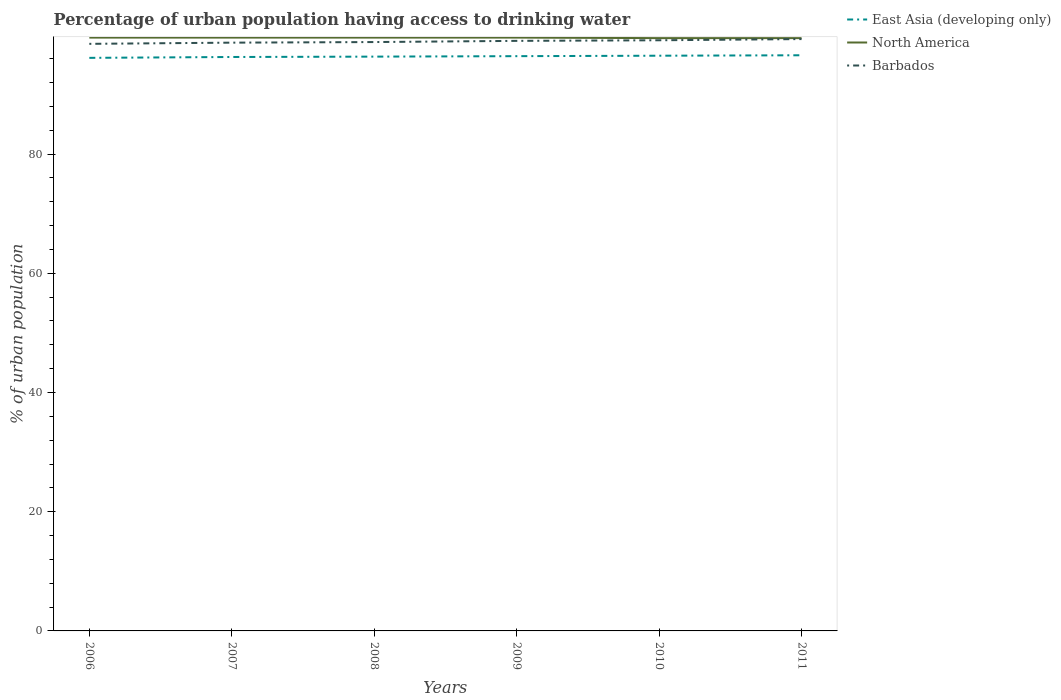Does the line corresponding to Barbados intersect with the line corresponding to East Asia (developing only)?
Give a very brief answer. No. Is the number of lines equal to the number of legend labels?
Your response must be concise. Yes. Across all years, what is the maximum percentage of urban population having access to drinking water in East Asia (developing only)?
Your response must be concise. 96.15. What is the total percentage of urban population having access to drinking water in East Asia (developing only) in the graph?
Your answer should be compact. -0.23. What is the difference between the highest and the second highest percentage of urban population having access to drinking water in East Asia (developing only)?
Give a very brief answer. 0.43. What is the difference between the highest and the lowest percentage of urban population having access to drinking water in North America?
Offer a very short reply. 4. Is the percentage of urban population having access to drinking water in East Asia (developing only) strictly greater than the percentage of urban population having access to drinking water in Barbados over the years?
Your answer should be compact. Yes. How many lines are there?
Give a very brief answer. 3. How many years are there in the graph?
Provide a short and direct response. 6. Does the graph contain grids?
Your answer should be very brief. No. How are the legend labels stacked?
Keep it short and to the point. Vertical. What is the title of the graph?
Your answer should be compact. Percentage of urban population having access to drinking water. What is the label or title of the Y-axis?
Ensure brevity in your answer.  % of urban population. What is the % of urban population of East Asia (developing only) in 2006?
Your answer should be very brief. 96.15. What is the % of urban population in North America in 2006?
Your answer should be compact. 99.55. What is the % of urban population of Barbados in 2006?
Provide a succinct answer. 98.5. What is the % of urban population of East Asia (developing only) in 2007?
Provide a short and direct response. 96.29. What is the % of urban population in North America in 2007?
Keep it short and to the point. 99.55. What is the % of urban population of Barbados in 2007?
Make the answer very short. 98.7. What is the % of urban population of East Asia (developing only) in 2008?
Your answer should be very brief. 96.36. What is the % of urban population in North America in 2008?
Make the answer very short. 99.55. What is the % of urban population of Barbados in 2008?
Provide a succinct answer. 98.8. What is the % of urban population of East Asia (developing only) in 2009?
Ensure brevity in your answer.  96.43. What is the % of urban population in North America in 2009?
Make the answer very short. 99.55. What is the % of urban population of East Asia (developing only) in 2010?
Make the answer very short. 96.51. What is the % of urban population in North America in 2010?
Keep it short and to the point. 99.46. What is the % of urban population of Barbados in 2010?
Offer a very short reply. 99.1. What is the % of urban population in East Asia (developing only) in 2011?
Ensure brevity in your answer.  96.58. What is the % of urban population in North America in 2011?
Your response must be concise. 99.46. What is the % of urban population of Barbados in 2011?
Offer a very short reply. 99.3. Across all years, what is the maximum % of urban population of East Asia (developing only)?
Your response must be concise. 96.58. Across all years, what is the maximum % of urban population of North America?
Make the answer very short. 99.55. Across all years, what is the maximum % of urban population in Barbados?
Ensure brevity in your answer.  99.3. Across all years, what is the minimum % of urban population of East Asia (developing only)?
Make the answer very short. 96.15. Across all years, what is the minimum % of urban population in North America?
Offer a terse response. 99.46. Across all years, what is the minimum % of urban population of Barbados?
Your answer should be compact. 98.5. What is the total % of urban population in East Asia (developing only) in the graph?
Ensure brevity in your answer.  578.33. What is the total % of urban population in North America in the graph?
Keep it short and to the point. 597.12. What is the total % of urban population in Barbados in the graph?
Provide a succinct answer. 593.4. What is the difference between the % of urban population in East Asia (developing only) in 2006 and that in 2007?
Provide a short and direct response. -0.14. What is the difference between the % of urban population of North America in 2006 and that in 2007?
Give a very brief answer. -0. What is the difference between the % of urban population in Barbados in 2006 and that in 2007?
Your answer should be very brief. -0.2. What is the difference between the % of urban population of East Asia (developing only) in 2006 and that in 2008?
Your answer should be compact. -0.21. What is the difference between the % of urban population of North America in 2006 and that in 2008?
Your answer should be compact. -0. What is the difference between the % of urban population of East Asia (developing only) in 2006 and that in 2009?
Give a very brief answer. -0.28. What is the difference between the % of urban population of North America in 2006 and that in 2009?
Offer a terse response. -0. What is the difference between the % of urban population of Barbados in 2006 and that in 2009?
Make the answer very short. -0.5. What is the difference between the % of urban population in East Asia (developing only) in 2006 and that in 2010?
Give a very brief answer. -0.36. What is the difference between the % of urban population in North America in 2006 and that in 2010?
Make the answer very short. 0.09. What is the difference between the % of urban population in East Asia (developing only) in 2006 and that in 2011?
Provide a short and direct response. -0.43. What is the difference between the % of urban population in North America in 2006 and that in 2011?
Provide a short and direct response. 0.09. What is the difference between the % of urban population in East Asia (developing only) in 2007 and that in 2008?
Your answer should be compact. -0.06. What is the difference between the % of urban population of North America in 2007 and that in 2008?
Offer a terse response. -0. What is the difference between the % of urban population in Barbados in 2007 and that in 2008?
Make the answer very short. -0.1. What is the difference between the % of urban population in East Asia (developing only) in 2007 and that in 2009?
Provide a succinct answer. -0.14. What is the difference between the % of urban population of North America in 2007 and that in 2009?
Give a very brief answer. -0. What is the difference between the % of urban population in Barbados in 2007 and that in 2009?
Provide a succinct answer. -0.3. What is the difference between the % of urban population of East Asia (developing only) in 2007 and that in 2010?
Offer a very short reply. -0.22. What is the difference between the % of urban population in North America in 2007 and that in 2010?
Your answer should be compact. 0.09. What is the difference between the % of urban population in Barbados in 2007 and that in 2010?
Your answer should be compact. -0.4. What is the difference between the % of urban population of East Asia (developing only) in 2007 and that in 2011?
Your answer should be very brief. -0.29. What is the difference between the % of urban population in North America in 2007 and that in 2011?
Keep it short and to the point. 0.09. What is the difference between the % of urban population of East Asia (developing only) in 2008 and that in 2009?
Ensure brevity in your answer.  -0.08. What is the difference between the % of urban population of North America in 2008 and that in 2009?
Provide a succinct answer. -0. What is the difference between the % of urban population in East Asia (developing only) in 2008 and that in 2010?
Your answer should be compact. -0.15. What is the difference between the % of urban population in North America in 2008 and that in 2010?
Give a very brief answer. 0.09. What is the difference between the % of urban population of East Asia (developing only) in 2008 and that in 2011?
Offer a very short reply. -0.23. What is the difference between the % of urban population of North America in 2008 and that in 2011?
Ensure brevity in your answer.  0.09. What is the difference between the % of urban population in East Asia (developing only) in 2009 and that in 2010?
Provide a succinct answer. -0.08. What is the difference between the % of urban population of North America in 2009 and that in 2010?
Offer a very short reply. 0.09. What is the difference between the % of urban population in Barbados in 2009 and that in 2010?
Offer a terse response. -0.1. What is the difference between the % of urban population in East Asia (developing only) in 2009 and that in 2011?
Your response must be concise. -0.15. What is the difference between the % of urban population in North America in 2009 and that in 2011?
Provide a succinct answer. 0.09. What is the difference between the % of urban population in Barbados in 2009 and that in 2011?
Make the answer very short. -0.3. What is the difference between the % of urban population of East Asia (developing only) in 2010 and that in 2011?
Give a very brief answer. -0.07. What is the difference between the % of urban population in North America in 2010 and that in 2011?
Give a very brief answer. -0. What is the difference between the % of urban population of East Asia (developing only) in 2006 and the % of urban population of North America in 2007?
Offer a terse response. -3.4. What is the difference between the % of urban population in East Asia (developing only) in 2006 and the % of urban population in Barbados in 2007?
Your answer should be very brief. -2.55. What is the difference between the % of urban population of North America in 2006 and the % of urban population of Barbados in 2007?
Provide a short and direct response. 0.85. What is the difference between the % of urban population of East Asia (developing only) in 2006 and the % of urban population of North America in 2008?
Your answer should be compact. -3.4. What is the difference between the % of urban population in East Asia (developing only) in 2006 and the % of urban population in Barbados in 2008?
Keep it short and to the point. -2.65. What is the difference between the % of urban population of North America in 2006 and the % of urban population of Barbados in 2008?
Make the answer very short. 0.75. What is the difference between the % of urban population of East Asia (developing only) in 2006 and the % of urban population of North America in 2009?
Keep it short and to the point. -3.4. What is the difference between the % of urban population in East Asia (developing only) in 2006 and the % of urban population in Barbados in 2009?
Offer a very short reply. -2.85. What is the difference between the % of urban population of North America in 2006 and the % of urban population of Barbados in 2009?
Keep it short and to the point. 0.55. What is the difference between the % of urban population of East Asia (developing only) in 2006 and the % of urban population of North America in 2010?
Provide a short and direct response. -3.31. What is the difference between the % of urban population in East Asia (developing only) in 2006 and the % of urban population in Barbados in 2010?
Provide a succinct answer. -2.95. What is the difference between the % of urban population of North America in 2006 and the % of urban population of Barbados in 2010?
Provide a short and direct response. 0.45. What is the difference between the % of urban population of East Asia (developing only) in 2006 and the % of urban population of North America in 2011?
Your answer should be very brief. -3.31. What is the difference between the % of urban population of East Asia (developing only) in 2006 and the % of urban population of Barbados in 2011?
Offer a terse response. -3.15. What is the difference between the % of urban population in North America in 2006 and the % of urban population in Barbados in 2011?
Offer a very short reply. 0.25. What is the difference between the % of urban population of East Asia (developing only) in 2007 and the % of urban population of North America in 2008?
Ensure brevity in your answer.  -3.26. What is the difference between the % of urban population in East Asia (developing only) in 2007 and the % of urban population in Barbados in 2008?
Keep it short and to the point. -2.51. What is the difference between the % of urban population in North America in 2007 and the % of urban population in Barbados in 2008?
Provide a short and direct response. 0.75. What is the difference between the % of urban population in East Asia (developing only) in 2007 and the % of urban population in North America in 2009?
Offer a very short reply. -3.26. What is the difference between the % of urban population of East Asia (developing only) in 2007 and the % of urban population of Barbados in 2009?
Offer a terse response. -2.71. What is the difference between the % of urban population of North America in 2007 and the % of urban population of Barbados in 2009?
Ensure brevity in your answer.  0.55. What is the difference between the % of urban population in East Asia (developing only) in 2007 and the % of urban population in North America in 2010?
Offer a terse response. -3.17. What is the difference between the % of urban population of East Asia (developing only) in 2007 and the % of urban population of Barbados in 2010?
Ensure brevity in your answer.  -2.81. What is the difference between the % of urban population in North America in 2007 and the % of urban population in Barbados in 2010?
Offer a very short reply. 0.45. What is the difference between the % of urban population of East Asia (developing only) in 2007 and the % of urban population of North America in 2011?
Offer a very short reply. -3.17. What is the difference between the % of urban population of East Asia (developing only) in 2007 and the % of urban population of Barbados in 2011?
Your response must be concise. -3.01. What is the difference between the % of urban population in North America in 2007 and the % of urban population in Barbados in 2011?
Provide a short and direct response. 0.25. What is the difference between the % of urban population in East Asia (developing only) in 2008 and the % of urban population in North America in 2009?
Your response must be concise. -3.19. What is the difference between the % of urban population of East Asia (developing only) in 2008 and the % of urban population of Barbados in 2009?
Ensure brevity in your answer.  -2.64. What is the difference between the % of urban population of North America in 2008 and the % of urban population of Barbados in 2009?
Your answer should be compact. 0.55. What is the difference between the % of urban population in East Asia (developing only) in 2008 and the % of urban population in North America in 2010?
Keep it short and to the point. -3.1. What is the difference between the % of urban population in East Asia (developing only) in 2008 and the % of urban population in Barbados in 2010?
Your response must be concise. -2.74. What is the difference between the % of urban population of North America in 2008 and the % of urban population of Barbados in 2010?
Offer a terse response. 0.45. What is the difference between the % of urban population in East Asia (developing only) in 2008 and the % of urban population in North America in 2011?
Provide a short and direct response. -3.1. What is the difference between the % of urban population of East Asia (developing only) in 2008 and the % of urban population of Barbados in 2011?
Give a very brief answer. -2.94. What is the difference between the % of urban population of North America in 2008 and the % of urban population of Barbados in 2011?
Your answer should be compact. 0.25. What is the difference between the % of urban population in East Asia (developing only) in 2009 and the % of urban population in North America in 2010?
Offer a terse response. -3.03. What is the difference between the % of urban population of East Asia (developing only) in 2009 and the % of urban population of Barbados in 2010?
Provide a short and direct response. -2.67. What is the difference between the % of urban population of North America in 2009 and the % of urban population of Barbados in 2010?
Provide a succinct answer. 0.45. What is the difference between the % of urban population in East Asia (developing only) in 2009 and the % of urban population in North America in 2011?
Your answer should be compact. -3.03. What is the difference between the % of urban population of East Asia (developing only) in 2009 and the % of urban population of Barbados in 2011?
Ensure brevity in your answer.  -2.87. What is the difference between the % of urban population of North America in 2009 and the % of urban population of Barbados in 2011?
Provide a short and direct response. 0.25. What is the difference between the % of urban population in East Asia (developing only) in 2010 and the % of urban population in North America in 2011?
Offer a very short reply. -2.95. What is the difference between the % of urban population in East Asia (developing only) in 2010 and the % of urban population in Barbados in 2011?
Provide a succinct answer. -2.79. What is the difference between the % of urban population of North America in 2010 and the % of urban population of Barbados in 2011?
Keep it short and to the point. 0.16. What is the average % of urban population of East Asia (developing only) per year?
Offer a very short reply. 96.39. What is the average % of urban population in North America per year?
Offer a terse response. 99.52. What is the average % of urban population in Barbados per year?
Your answer should be compact. 98.9. In the year 2006, what is the difference between the % of urban population in East Asia (developing only) and % of urban population in North America?
Offer a very short reply. -3.4. In the year 2006, what is the difference between the % of urban population in East Asia (developing only) and % of urban population in Barbados?
Ensure brevity in your answer.  -2.35. In the year 2006, what is the difference between the % of urban population of North America and % of urban population of Barbados?
Your answer should be very brief. 1.05. In the year 2007, what is the difference between the % of urban population in East Asia (developing only) and % of urban population in North America?
Ensure brevity in your answer.  -3.26. In the year 2007, what is the difference between the % of urban population in East Asia (developing only) and % of urban population in Barbados?
Give a very brief answer. -2.41. In the year 2007, what is the difference between the % of urban population in North America and % of urban population in Barbados?
Offer a terse response. 0.85. In the year 2008, what is the difference between the % of urban population of East Asia (developing only) and % of urban population of North America?
Your response must be concise. -3.19. In the year 2008, what is the difference between the % of urban population in East Asia (developing only) and % of urban population in Barbados?
Your answer should be very brief. -2.44. In the year 2008, what is the difference between the % of urban population of North America and % of urban population of Barbados?
Your response must be concise. 0.75. In the year 2009, what is the difference between the % of urban population of East Asia (developing only) and % of urban population of North America?
Make the answer very short. -3.12. In the year 2009, what is the difference between the % of urban population of East Asia (developing only) and % of urban population of Barbados?
Your answer should be very brief. -2.57. In the year 2009, what is the difference between the % of urban population in North America and % of urban population in Barbados?
Your answer should be compact. 0.55. In the year 2010, what is the difference between the % of urban population in East Asia (developing only) and % of urban population in North America?
Provide a short and direct response. -2.95. In the year 2010, what is the difference between the % of urban population of East Asia (developing only) and % of urban population of Barbados?
Offer a very short reply. -2.59. In the year 2010, what is the difference between the % of urban population of North America and % of urban population of Barbados?
Your answer should be compact. 0.36. In the year 2011, what is the difference between the % of urban population of East Asia (developing only) and % of urban population of North America?
Provide a short and direct response. -2.88. In the year 2011, what is the difference between the % of urban population of East Asia (developing only) and % of urban population of Barbados?
Give a very brief answer. -2.72. In the year 2011, what is the difference between the % of urban population in North America and % of urban population in Barbados?
Offer a very short reply. 0.16. What is the ratio of the % of urban population of East Asia (developing only) in 2006 to that in 2007?
Offer a terse response. 1. What is the ratio of the % of urban population in East Asia (developing only) in 2006 to that in 2008?
Ensure brevity in your answer.  1. What is the ratio of the % of urban population in North America in 2006 to that in 2008?
Your response must be concise. 1. What is the ratio of the % of urban population in East Asia (developing only) in 2006 to that in 2009?
Make the answer very short. 1. What is the ratio of the % of urban population in North America in 2006 to that in 2009?
Offer a very short reply. 1. What is the ratio of the % of urban population in Barbados in 2006 to that in 2009?
Make the answer very short. 0.99. What is the ratio of the % of urban population in East Asia (developing only) in 2006 to that in 2010?
Your response must be concise. 1. What is the ratio of the % of urban population in Barbados in 2006 to that in 2010?
Your answer should be compact. 0.99. What is the ratio of the % of urban population in East Asia (developing only) in 2007 to that in 2008?
Ensure brevity in your answer.  1. What is the ratio of the % of urban population in East Asia (developing only) in 2007 to that in 2009?
Keep it short and to the point. 1. What is the ratio of the % of urban population in Barbados in 2007 to that in 2009?
Offer a terse response. 1. What is the ratio of the % of urban population in Barbados in 2007 to that in 2010?
Your response must be concise. 1. What is the ratio of the % of urban population of North America in 2007 to that in 2011?
Provide a short and direct response. 1. What is the ratio of the % of urban population of East Asia (developing only) in 2008 to that in 2009?
Provide a short and direct response. 1. What is the ratio of the % of urban population in North America in 2008 to that in 2009?
Your answer should be compact. 1. What is the ratio of the % of urban population in East Asia (developing only) in 2008 to that in 2010?
Your response must be concise. 1. What is the ratio of the % of urban population of East Asia (developing only) in 2009 to that in 2010?
Provide a succinct answer. 1. What is the ratio of the % of urban population in North America in 2009 to that in 2010?
Give a very brief answer. 1. What is the ratio of the % of urban population in East Asia (developing only) in 2009 to that in 2011?
Keep it short and to the point. 1. What is the ratio of the % of urban population of North America in 2009 to that in 2011?
Provide a short and direct response. 1. What is the ratio of the % of urban population in Barbados in 2009 to that in 2011?
Offer a terse response. 1. What is the ratio of the % of urban population of East Asia (developing only) in 2010 to that in 2011?
Give a very brief answer. 1. What is the ratio of the % of urban population of Barbados in 2010 to that in 2011?
Provide a succinct answer. 1. What is the difference between the highest and the second highest % of urban population in East Asia (developing only)?
Offer a terse response. 0.07. What is the difference between the highest and the lowest % of urban population in East Asia (developing only)?
Ensure brevity in your answer.  0.43. What is the difference between the highest and the lowest % of urban population in North America?
Offer a terse response. 0.09. What is the difference between the highest and the lowest % of urban population of Barbados?
Make the answer very short. 0.8. 